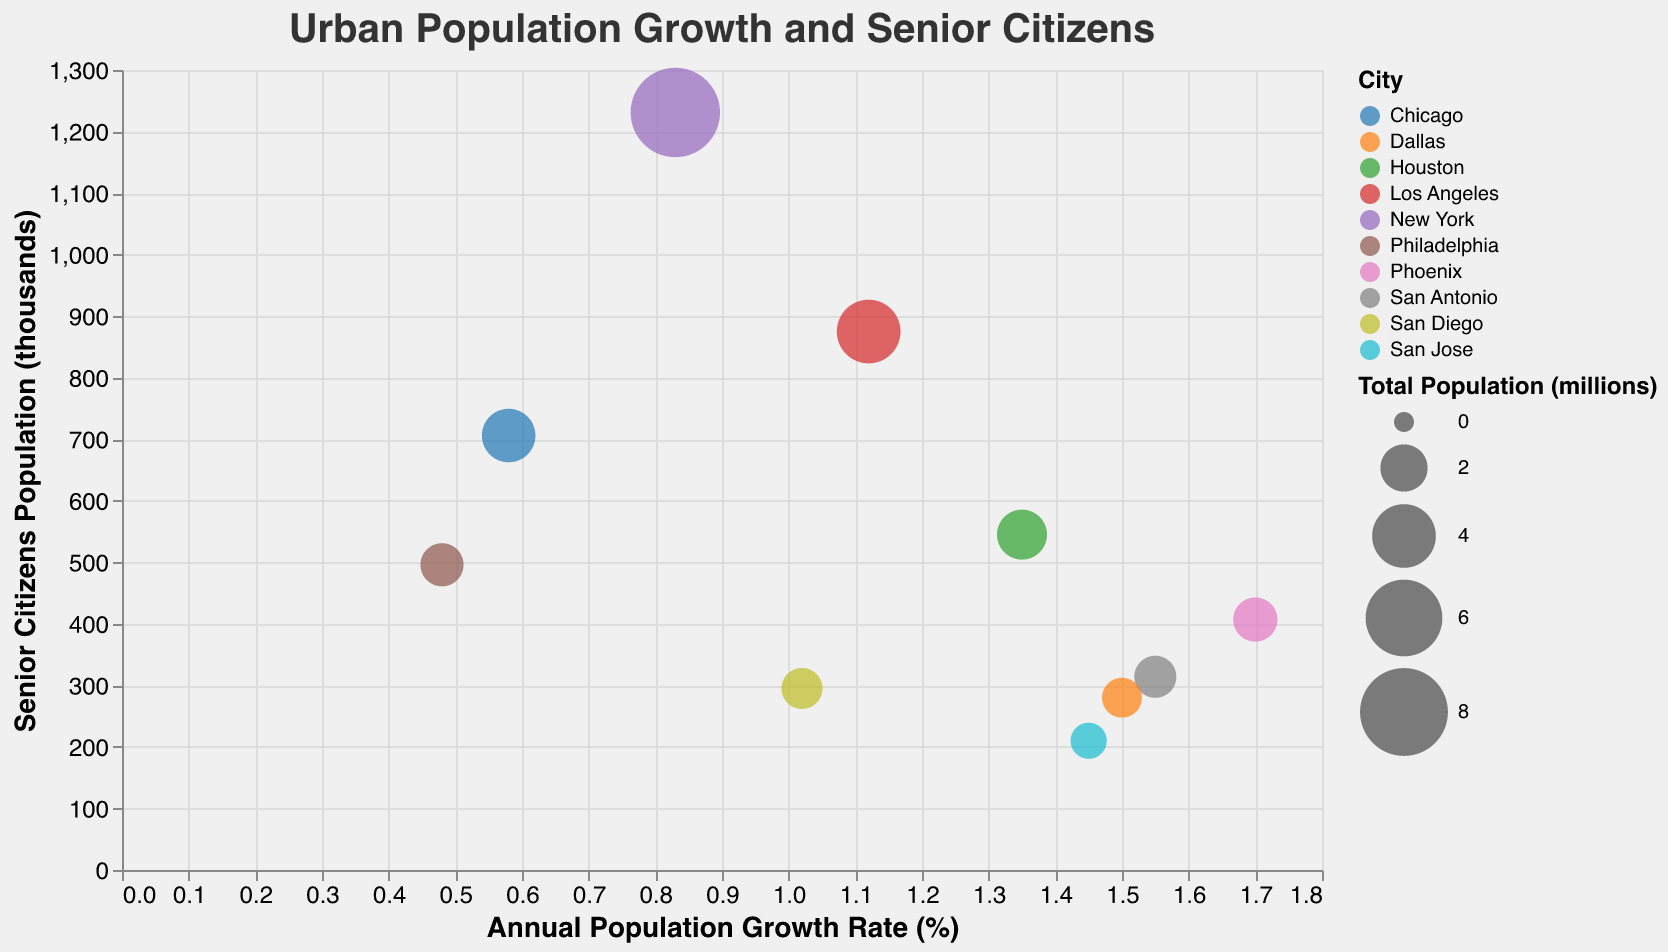What is the title of the chart? The title is the text displayed at the top of the figure, indicating its main subject.
Answer: Urban Population Growth and Senior Citizens How many cities are represented in the chart? Count the number of distinct data points, each represented by a bubble.
Answer: 10 Which city has the highest population growth rate? Look at the x-axis and find the bubble farthest to the right. The tooltip can help to confirm the exact values.
Answer: Phoenix Which city has the largest population of senior citizens? Look at the y-axis and find the bubble highest up on the chart. The tooltip provides the exact values.
Answer: New York Which city has the smallest total population? Look at the size of the bubbles; the smallest ones have the least total population. Use the tooltip for confirmation.
Answer: San Jose What is the population growth rate of San Antonio? Hover over San Antonio's bubble to check the tooltip that shows the growth rate.
Answer: 1.55% What is the combined population of senior citizens in New York and Los Angeles? Find the senior citizen populations from the tooltip for both cities (1231 + 875).
Answer: 2106 thousand Which city has a higher population growth rate, Los Angeles or San Diego? Compare the x-axis positions of both cities' bubbles. The tooltip provides exact values.
Answer: Los Angeles What is the difference in the senior citizen population between Philadelphia and Chicago? Find the populations from the tooltip (496 for Philadelphia, 706 for Chicago) and subtract.
Answer: 210 thousand Which city has a smaller population growth rate, Houston or Dallas? Compare the x-axis positions of their bubbles. The tooltip provides exact values.
Answer: Dallas 